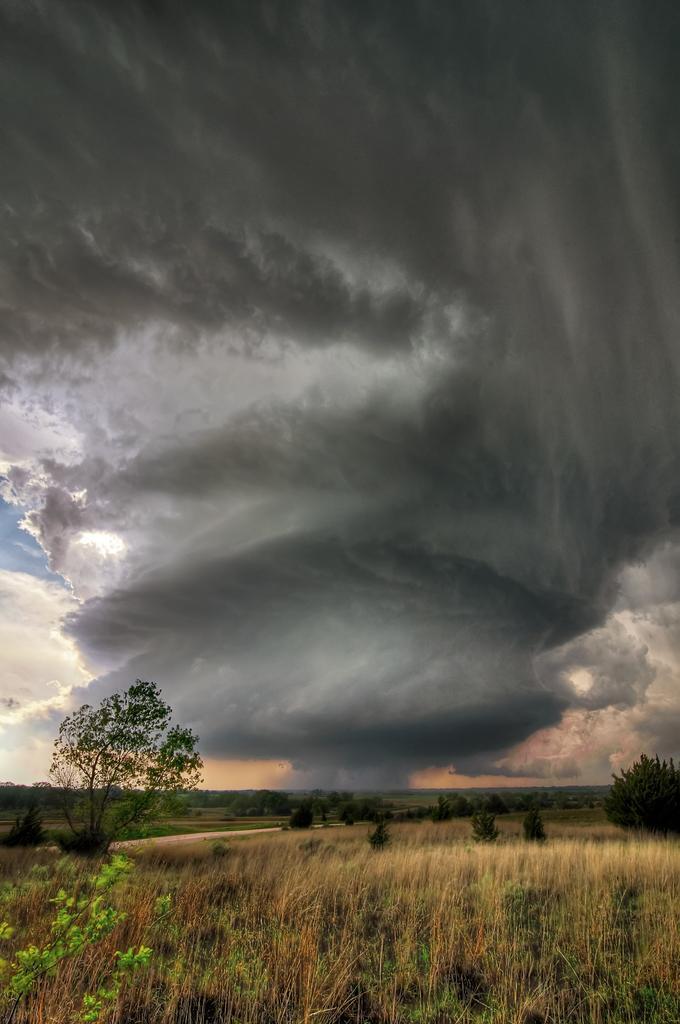Can you describe this image briefly? In the foreground we can see the grass. In the background, we can see the trees. This is a sky with clouds. 